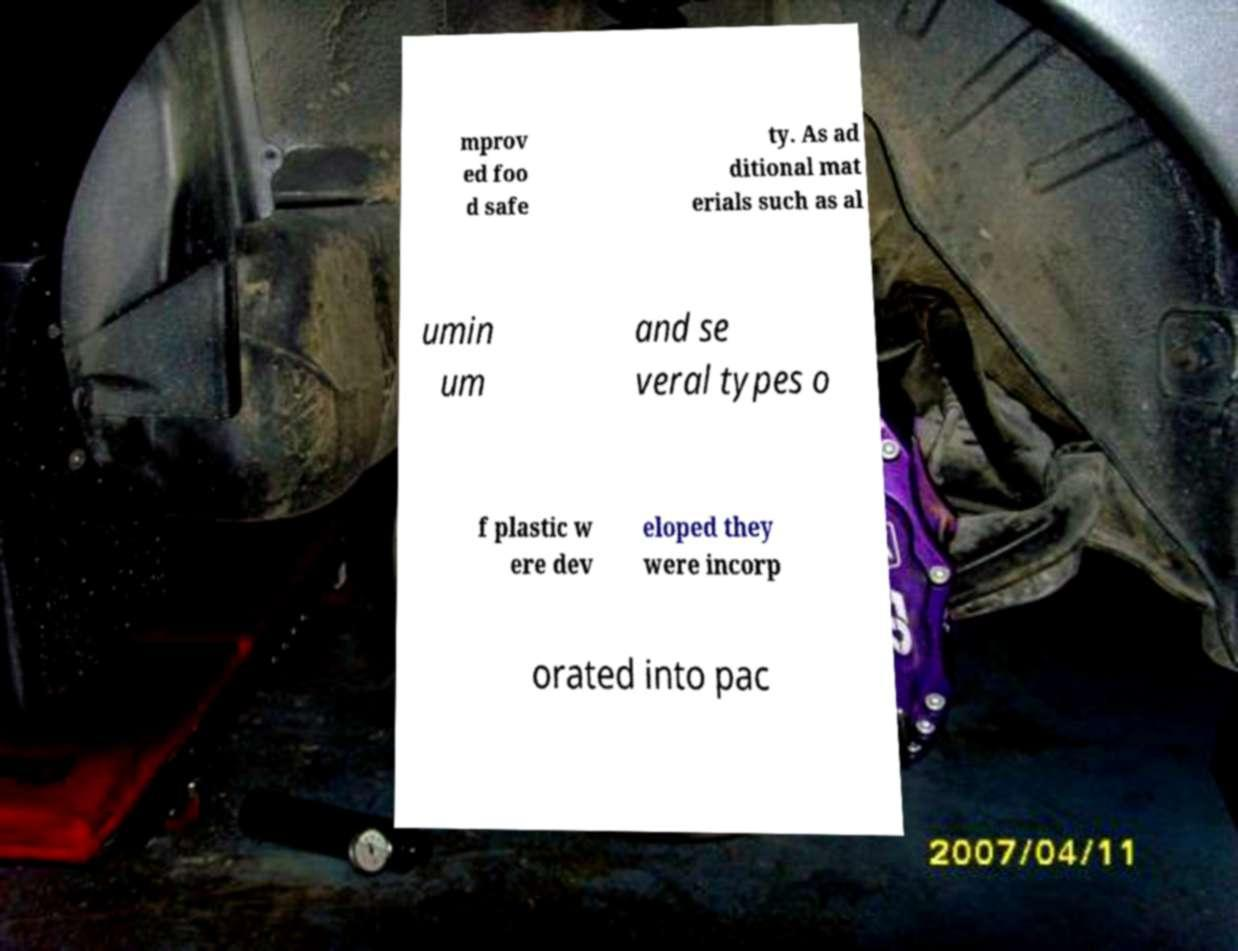Can you accurately transcribe the text from the provided image for me? mprov ed foo d safe ty. As ad ditional mat erials such as al umin um and se veral types o f plastic w ere dev eloped they were incorp orated into pac 